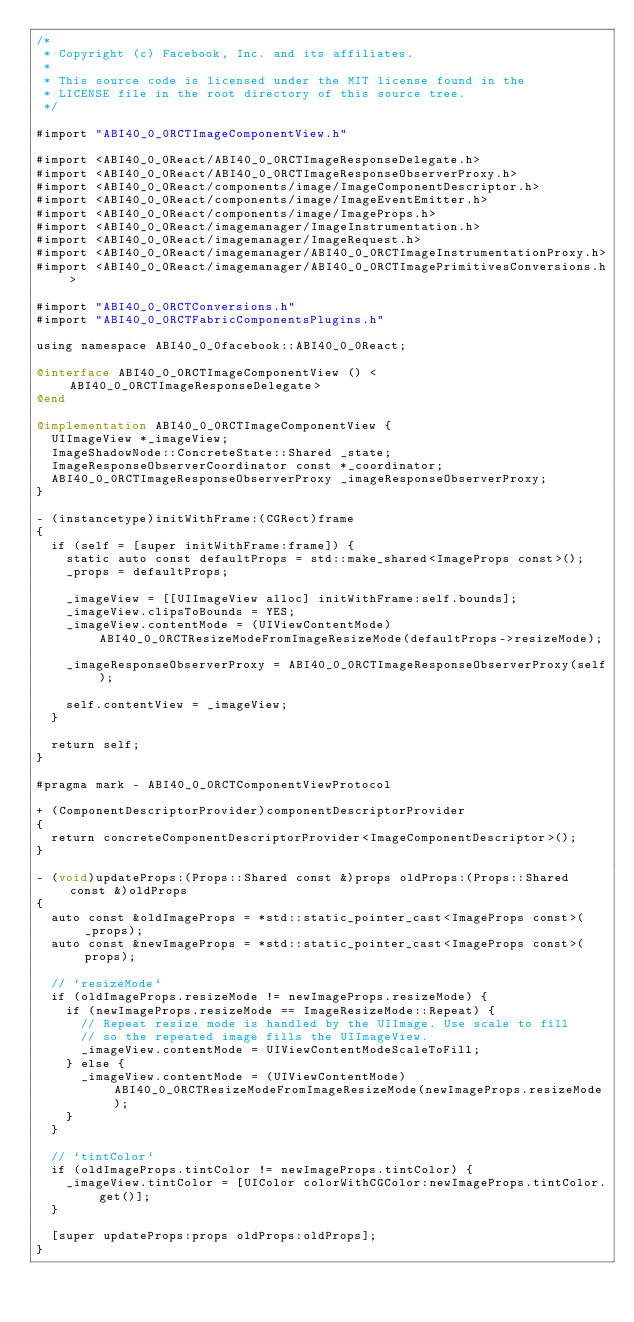Convert code to text. <code><loc_0><loc_0><loc_500><loc_500><_ObjectiveC_>/*
 * Copyright (c) Facebook, Inc. and its affiliates.
 *
 * This source code is licensed under the MIT license found in the
 * LICENSE file in the root directory of this source tree.
 */

#import "ABI40_0_0RCTImageComponentView.h"

#import <ABI40_0_0React/ABI40_0_0RCTImageResponseDelegate.h>
#import <ABI40_0_0React/ABI40_0_0RCTImageResponseObserverProxy.h>
#import <ABI40_0_0React/components/image/ImageComponentDescriptor.h>
#import <ABI40_0_0React/components/image/ImageEventEmitter.h>
#import <ABI40_0_0React/components/image/ImageProps.h>
#import <ABI40_0_0React/imagemanager/ImageInstrumentation.h>
#import <ABI40_0_0React/imagemanager/ImageRequest.h>
#import <ABI40_0_0React/imagemanager/ABI40_0_0RCTImageInstrumentationProxy.h>
#import <ABI40_0_0React/imagemanager/ABI40_0_0RCTImagePrimitivesConversions.h>

#import "ABI40_0_0RCTConversions.h"
#import "ABI40_0_0RCTFabricComponentsPlugins.h"

using namespace ABI40_0_0facebook::ABI40_0_0React;

@interface ABI40_0_0RCTImageComponentView () <ABI40_0_0RCTImageResponseDelegate>
@end

@implementation ABI40_0_0RCTImageComponentView {
  UIImageView *_imageView;
  ImageShadowNode::ConcreteState::Shared _state;
  ImageResponseObserverCoordinator const *_coordinator;
  ABI40_0_0RCTImageResponseObserverProxy _imageResponseObserverProxy;
}

- (instancetype)initWithFrame:(CGRect)frame
{
  if (self = [super initWithFrame:frame]) {
    static auto const defaultProps = std::make_shared<ImageProps const>();
    _props = defaultProps;

    _imageView = [[UIImageView alloc] initWithFrame:self.bounds];
    _imageView.clipsToBounds = YES;
    _imageView.contentMode = (UIViewContentMode)ABI40_0_0RCTResizeModeFromImageResizeMode(defaultProps->resizeMode);

    _imageResponseObserverProxy = ABI40_0_0RCTImageResponseObserverProxy(self);

    self.contentView = _imageView;
  }

  return self;
}

#pragma mark - ABI40_0_0RCTComponentViewProtocol

+ (ComponentDescriptorProvider)componentDescriptorProvider
{
  return concreteComponentDescriptorProvider<ImageComponentDescriptor>();
}

- (void)updateProps:(Props::Shared const &)props oldProps:(Props::Shared const &)oldProps
{
  auto const &oldImageProps = *std::static_pointer_cast<ImageProps const>(_props);
  auto const &newImageProps = *std::static_pointer_cast<ImageProps const>(props);

  // `resizeMode`
  if (oldImageProps.resizeMode != newImageProps.resizeMode) {
    if (newImageProps.resizeMode == ImageResizeMode::Repeat) {
      // Repeat resize mode is handled by the UIImage. Use scale to fill
      // so the repeated image fills the UIImageView.
      _imageView.contentMode = UIViewContentModeScaleToFill;
    } else {
      _imageView.contentMode = (UIViewContentMode)ABI40_0_0RCTResizeModeFromImageResizeMode(newImageProps.resizeMode);
    }
  }

  // `tintColor`
  if (oldImageProps.tintColor != newImageProps.tintColor) {
    _imageView.tintColor = [UIColor colorWithCGColor:newImageProps.tintColor.get()];
  }

  [super updateProps:props oldProps:oldProps];
}
</code> 